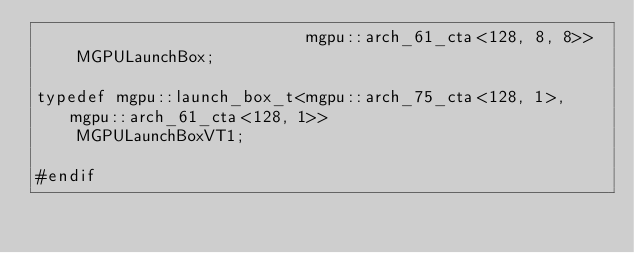Convert code to text. <code><loc_0><loc_0><loc_500><loc_500><_Cuda_>                           mgpu::arch_61_cta<128, 8, 8>>
    MGPULaunchBox;

typedef mgpu::launch_box_t<mgpu::arch_75_cta<128, 1>, mgpu::arch_61_cta<128, 1>>
    MGPULaunchBoxVT1;

#endif
</code> 